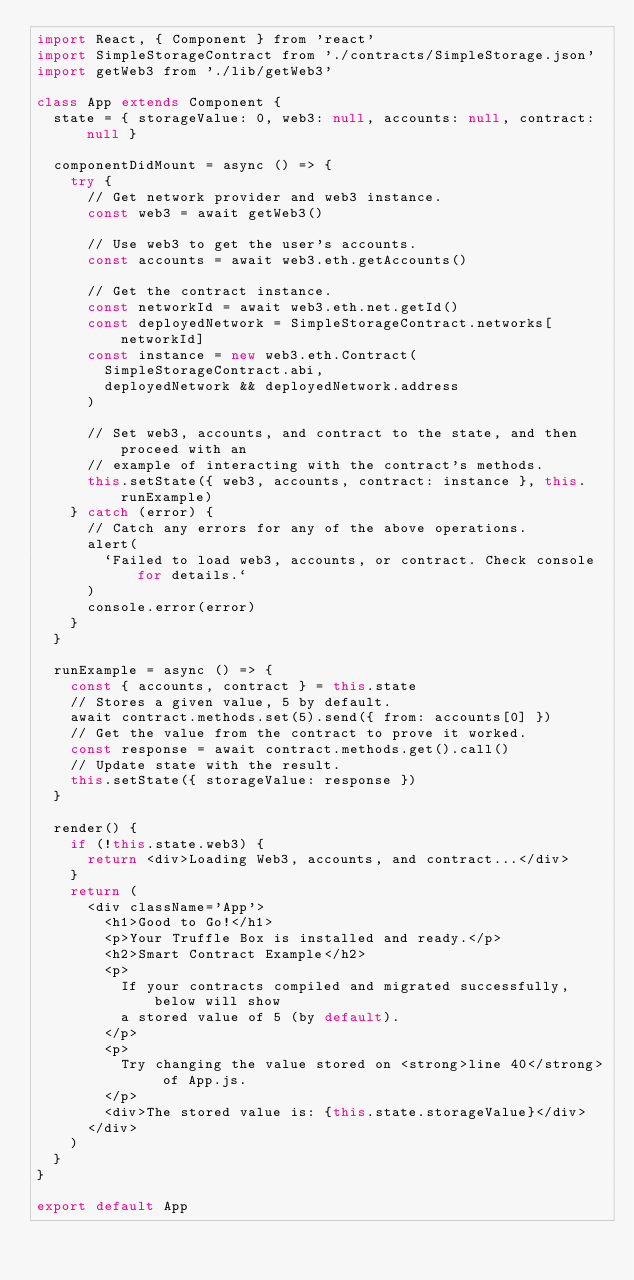<code> <loc_0><loc_0><loc_500><loc_500><_JavaScript_>import React, { Component } from 'react'
import SimpleStorageContract from './contracts/SimpleStorage.json'
import getWeb3 from './lib/getWeb3'

class App extends Component {
  state = { storageValue: 0, web3: null, accounts: null, contract: null }

  componentDidMount = async () => {
    try {
      // Get network provider and web3 instance.
      const web3 = await getWeb3()

      // Use web3 to get the user's accounts.
      const accounts = await web3.eth.getAccounts()

      // Get the contract instance.
      const networkId = await web3.eth.net.getId()
      const deployedNetwork = SimpleStorageContract.networks[networkId]
      const instance = new web3.eth.Contract(
        SimpleStorageContract.abi,
        deployedNetwork && deployedNetwork.address
      )

      // Set web3, accounts, and contract to the state, and then proceed with an
      // example of interacting with the contract's methods.
      this.setState({ web3, accounts, contract: instance }, this.runExample)
    } catch (error) {
      // Catch any errors for any of the above operations.
      alert(
        `Failed to load web3, accounts, or contract. Check console for details.`
      )
      console.error(error)
    }
  }

  runExample = async () => {
    const { accounts, contract } = this.state
    // Stores a given value, 5 by default.
    await contract.methods.set(5).send({ from: accounts[0] })
    // Get the value from the contract to prove it worked.
    const response = await contract.methods.get().call()
    // Update state with the result.
    this.setState({ storageValue: response })
  }

  render() {
    if (!this.state.web3) {
      return <div>Loading Web3, accounts, and contract...</div>
    }
    return (
      <div className='App'>
        <h1>Good to Go!</h1>
        <p>Your Truffle Box is installed and ready.</p>
        <h2>Smart Contract Example</h2>
        <p>
          If your contracts compiled and migrated successfully, below will show
          a stored value of 5 (by default).
        </p>
        <p>
          Try changing the value stored on <strong>line 40</strong> of App.js.
        </p>
        <div>The stored value is: {this.state.storageValue}</div>
      </div>
    )
  }
}

export default App
</code> 